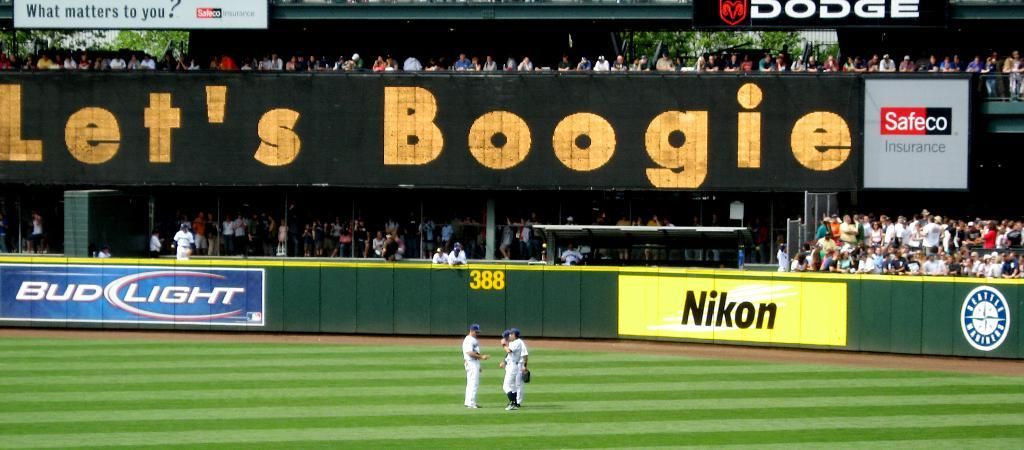<image>
Share a concise interpretation of the image provided. A big screen behind a baseball field says "Let's Boogie". 